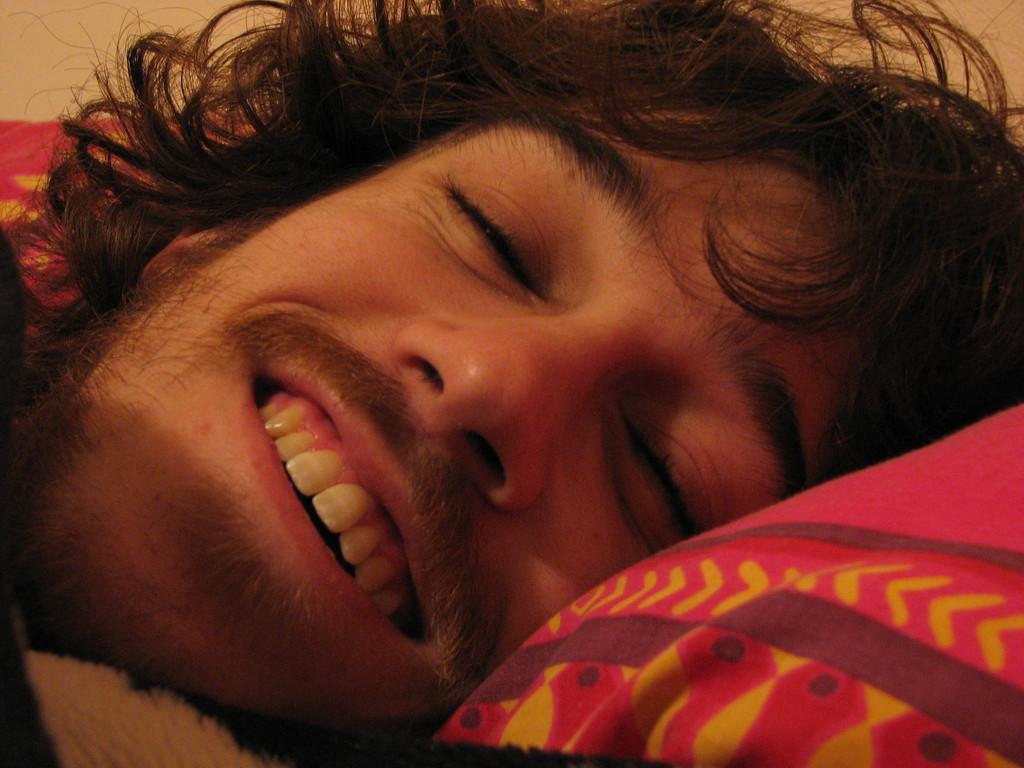In one or two sentences, can you explain what this image depicts? In this image, we can see a person sleeping on an object. 